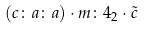Convert formula to latex. <formula><loc_0><loc_0><loc_500><loc_500>( c \colon a \colon a ) \cdot m \colon 4 _ { 2 } \cdot \tilde { c }</formula> 